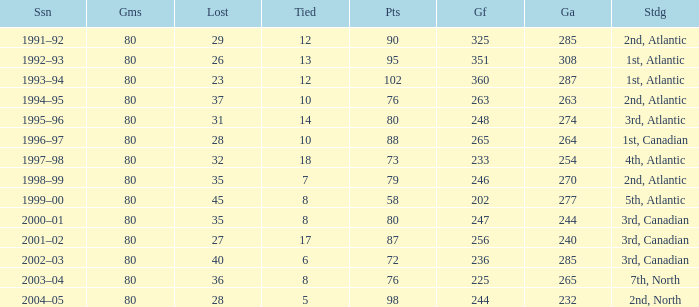How many goals against have 58 points? 277.0. Help me parse the entirety of this table. {'header': ['Ssn', 'Gms', 'Lost', 'Tied', 'Pts', 'Gf', 'Ga', 'Stdg'], 'rows': [['1991–92', '80', '29', '12', '90', '325', '285', '2nd, Atlantic'], ['1992–93', '80', '26', '13', '95', '351', '308', '1st, Atlantic'], ['1993–94', '80', '23', '12', '102', '360', '287', '1st, Atlantic'], ['1994–95', '80', '37', '10', '76', '263', '263', '2nd, Atlantic'], ['1995–96', '80', '31', '14', '80', '248', '274', '3rd, Atlantic'], ['1996–97', '80', '28', '10', '88', '265', '264', '1st, Canadian'], ['1997–98', '80', '32', '18', '73', '233', '254', '4th, Atlantic'], ['1998–99', '80', '35', '7', '79', '246', '270', '2nd, Atlantic'], ['1999–00', '80', '45', '8', '58', '202', '277', '5th, Atlantic'], ['2000–01', '80', '35', '8', '80', '247', '244', '3rd, Canadian'], ['2001–02', '80', '27', '17', '87', '256', '240', '3rd, Canadian'], ['2002–03', '80', '40', '6', '72', '236', '285', '3rd, Canadian'], ['2003–04', '80', '36', '8', '76', '225', '265', '7th, North'], ['2004–05', '80', '28', '5', '98', '244', '232', '2nd, North']]} 